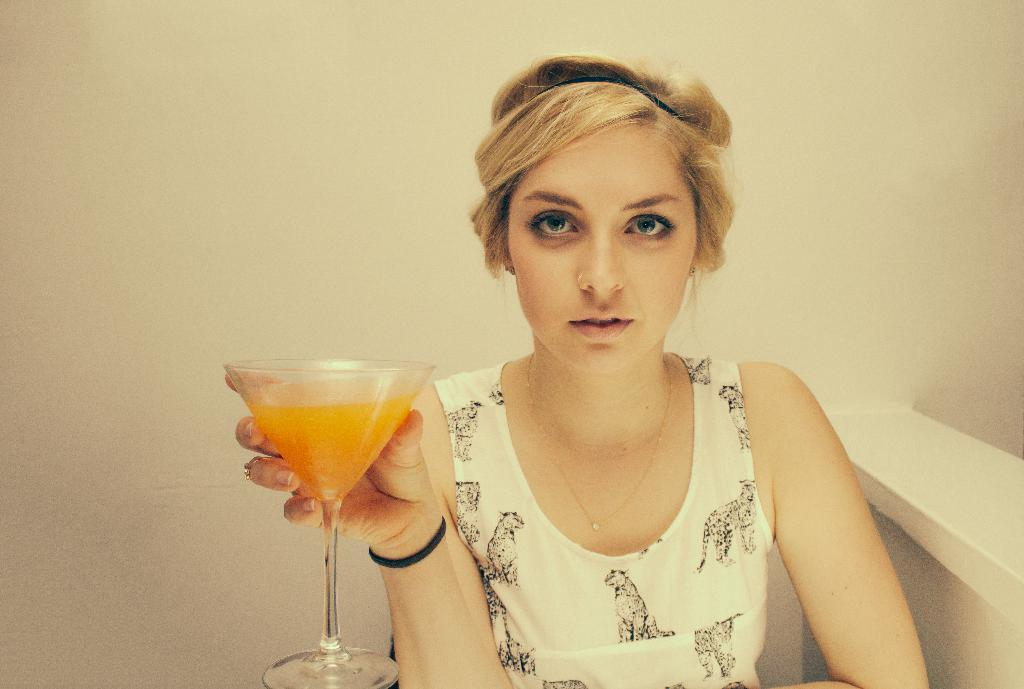Who is present in the image? There is a woman in the image. What is the woman doing in the image? The woman is sitting. What is the woman holding in her hand? The woman is holding a glass of juice in her hand. What type of cork can be seen in the woman's hair in the image? There is no cork present in the woman's hair or anywhere else in the image. 